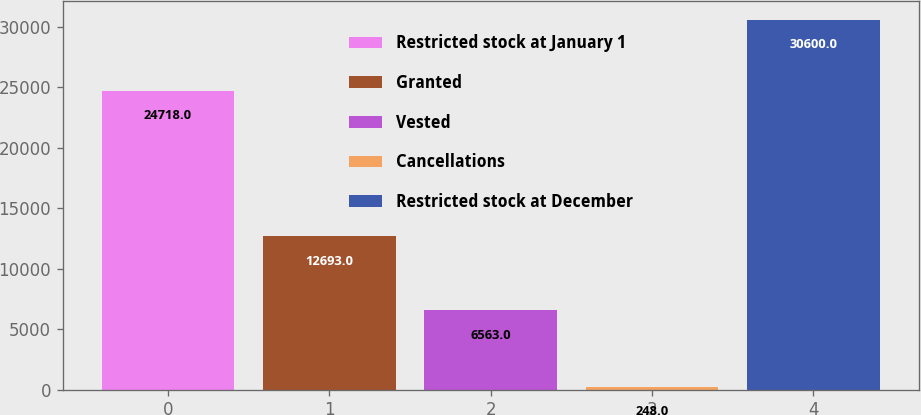Convert chart. <chart><loc_0><loc_0><loc_500><loc_500><bar_chart><fcel>Restricted stock at January 1<fcel>Granted<fcel>Vested<fcel>Cancellations<fcel>Restricted stock at December<nl><fcel>24718<fcel>12693<fcel>6563<fcel>248<fcel>30600<nl></chart> 